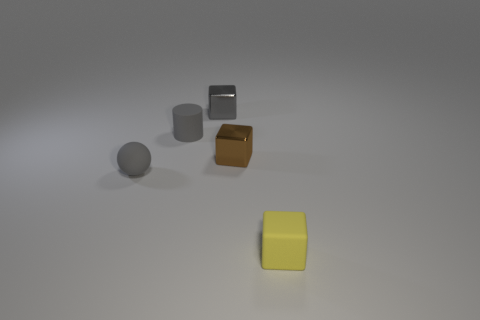There is a metal object in front of the small metallic cube behind the tiny cylinder; how big is it?
Keep it short and to the point. Small. What color is the cube that is the same material as the sphere?
Offer a very short reply. Yellow. What number of brown metal objects have the same size as the gray matte sphere?
Your answer should be compact. 1. How many red things are tiny shiny blocks or small blocks?
Provide a succinct answer. 0. What number of things are either yellow rubber blocks or objects that are behind the tiny gray rubber cylinder?
Make the answer very short. 2. What is the material of the gray object to the right of the gray rubber cylinder?
Keep it short and to the point. Metal. What is the shape of the gray shiny thing that is the same size as the gray cylinder?
Your answer should be compact. Cube. Is there a large brown rubber object that has the same shape as the yellow rubber thing?
Ensure brevity in your answer.  No. Do the small yellow object and the small object that is on the left side of the cylinder have the same material?
Your answer should be very brief. Yes. There is a gray object that is in front of the small metal block that is right of the gray metallic object; what is its material?
Keep it short and to the point. Rubber. 